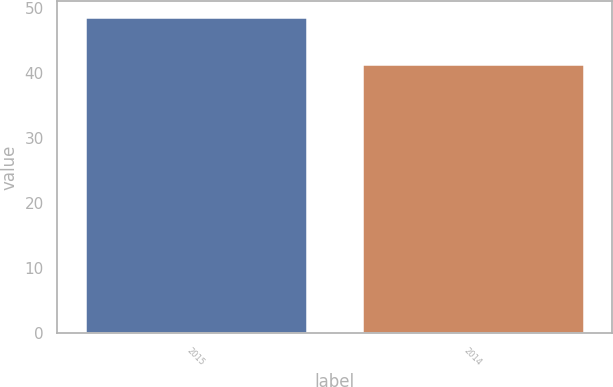Convert chart to OTSL. <chart><loc_0><loc_0><loc_500><loc_500><bar_chart><fcel>2015<fcel>2014<nl><fcel>48.66<fcel>41.41<nl></chart> 